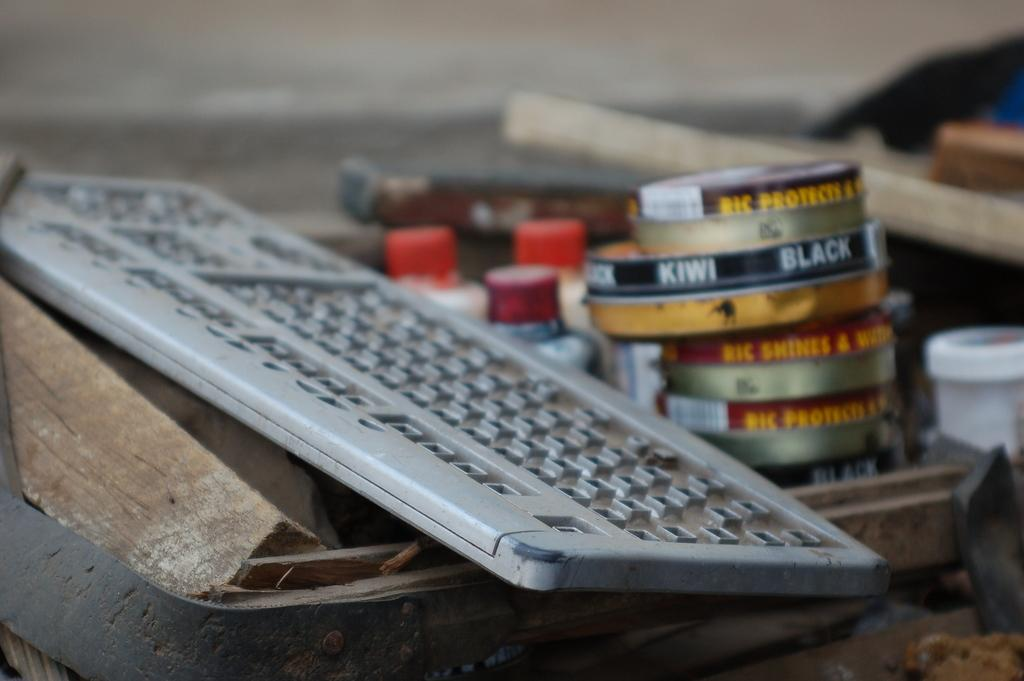<image>
Summarize the visual content of the image. Old keyboard next to some cans and one saying Kiwi Black. 